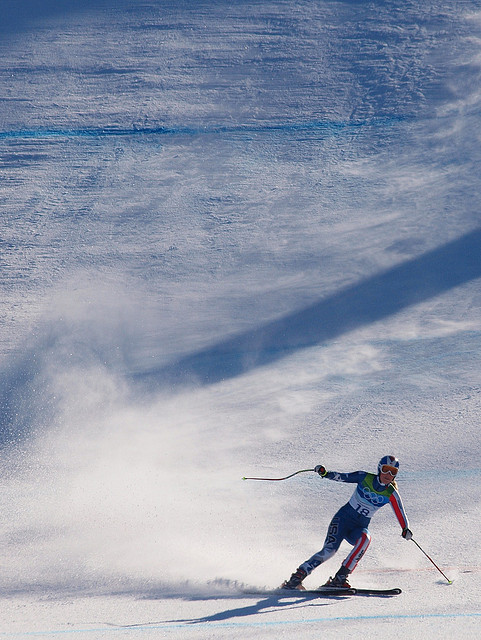<image>What safety equipment is the man using? I am not sure the man is using some sort of safety equipment. It can be a helmet or ski poles. What safety equipment is the man using? The man is using a helmet for safety. 